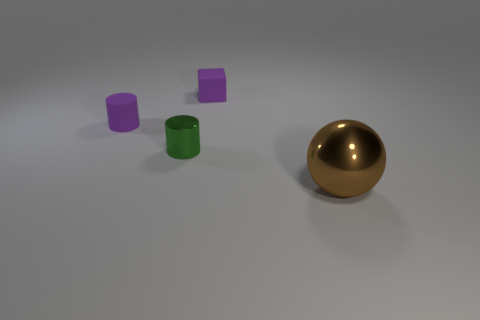What number of other things are the same material as the big brown ball?
Your answer should be very brief. 1. What size is the thing that is right of the small green cylinder and behind the big brown metal ball?
Provide a short and direct response. Small. How many spheres are the same size as the rubber block?
Give a very brief answer. 0. How big is the matte thing behind the purple matte object that is to the left of the tiny purple matte block?
Make the answer very short. Small. There is a thing in front of the small metallic cylinder; does it have the same shape as the small purple object in front of the tiny purple rubber cube?
Keep it short and to the point. No. What is the color of the object that is both behind the metal cylinder and right of the shiny cylinder?
Make the answer very short. Purple. Is there a cylinder of the same color as the small matte cube?
Offer a terse response. Yes. There is a shiny thing that is behind the large shiny object; what is its color?
Provide a short and direct response. Green. There is a tiny purple object that is left of the small block; is there a tiny purple cube in front of it?
Your answer should be compact. No. Does the matte cube have the same color as the small cylinder that is left of the small green metallic cylinder?
Give a very brief answer. Yes. 